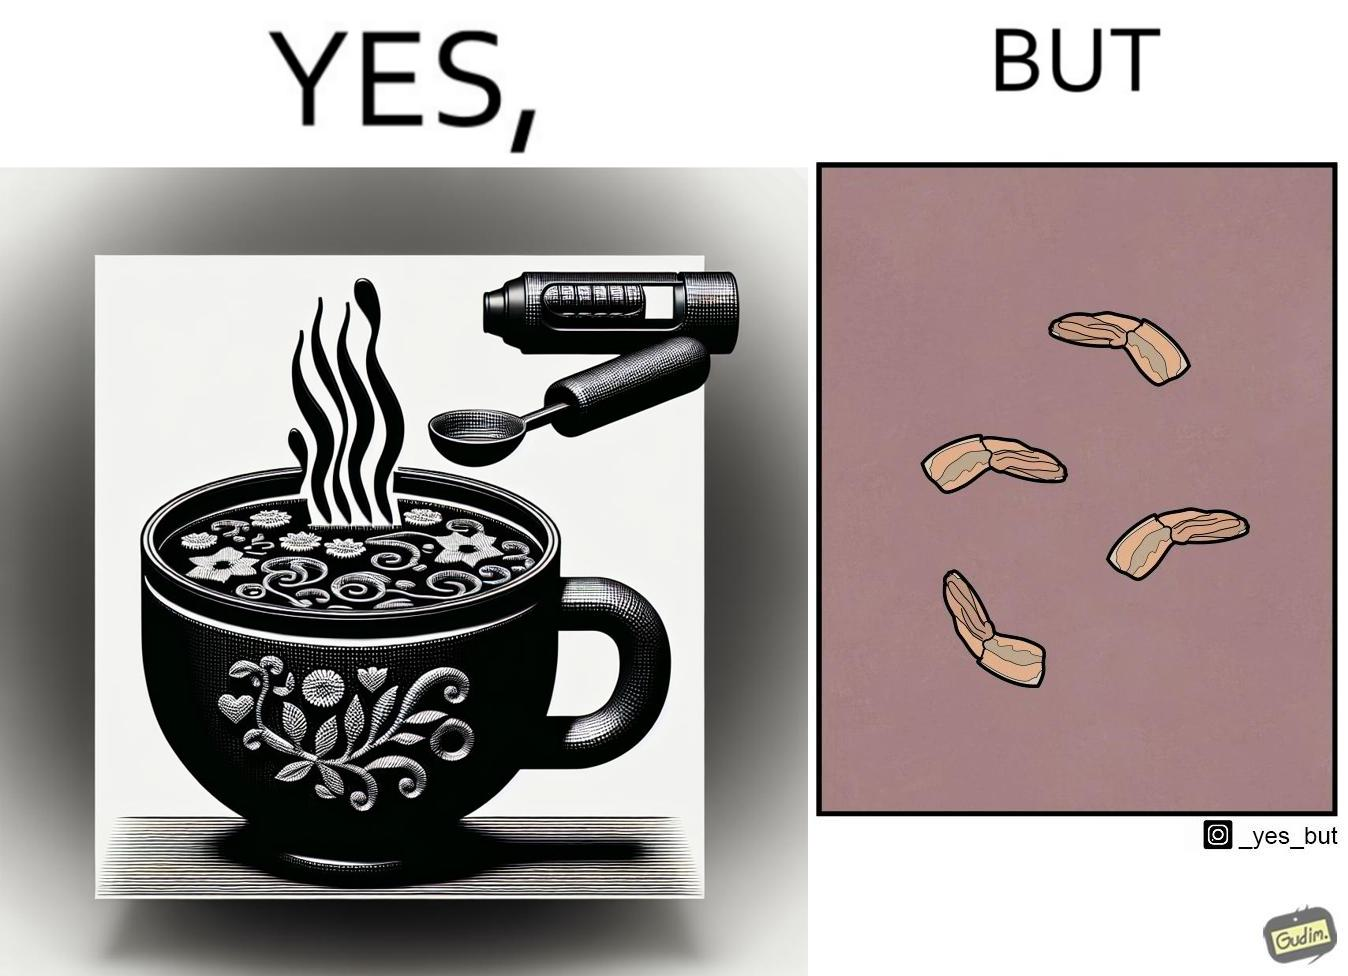Explain the humor or irony in this image. when we drink the whole soup, then  it is very healthy. But people eliminate some things which they don't like. 